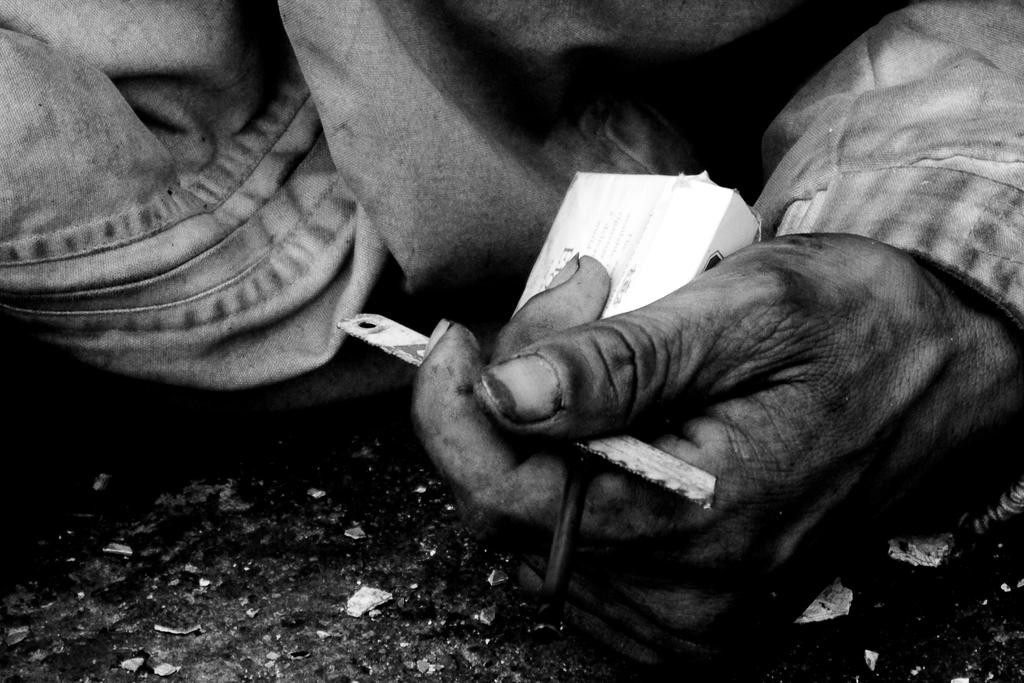What is the main subject of the image? There is a person in the image. What is the person holding in the image? The person is holding a box and a blade. What type of invention can be seen in the background of the image? There is no invention visible in the image; it only shows a person holding a box and a blade. How many pets are present in the image? There are no pets present in the image. 